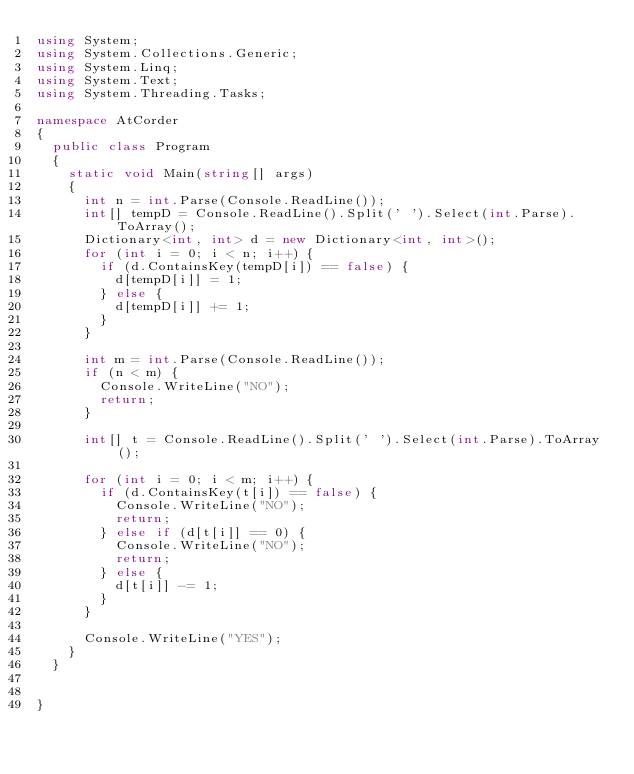Convert code to text. <code><loc_0><loc_0><loc_500><loc_500><_C#_>using System;
using System.Collections.Generic;
using System.Linq;
using System.Text;
using System.Threading.Tasks;

namespace AtCorder
{
	public class Program
	{
		static void Main(string[] args)
		{
			int n = int.Parse(Console.ReadLine());
			int[] tempD = Console.ReadLine().Split(' ').Select(int.Parse).ToArray();
			Dictionary<int, int> d = new Dictionary<int, int>();
			for (int i = 0; i < n; i++) {
				if (d.ContainsKey(tempD[i]) == false) {
					d[tempD[i]] = 1;
				} else {
					d[tempD[i]] += 1;
				}
			}

			int m = int.Parse(Console.ReadLine());
			if (n < m) {
				Console.WriteLine("NO");
				return;
			}

			int[] t = Console.ReadLine().Split(' ').Select(int.Parse).ToArray();

			for (int i = 0; i < m; i++) {
				if (d.ContainsKey(t[i]) == false) {
					Console.WriteLine("NO");
					return;
				} else if (d[t[i]] == 0) {
					Console.WriteLine("NO");
					return;
				} else {
					d[t[i]] -= 1;
				}
			}

			Console.WriteLine("YES");
		}
	}

	
}
</code> 